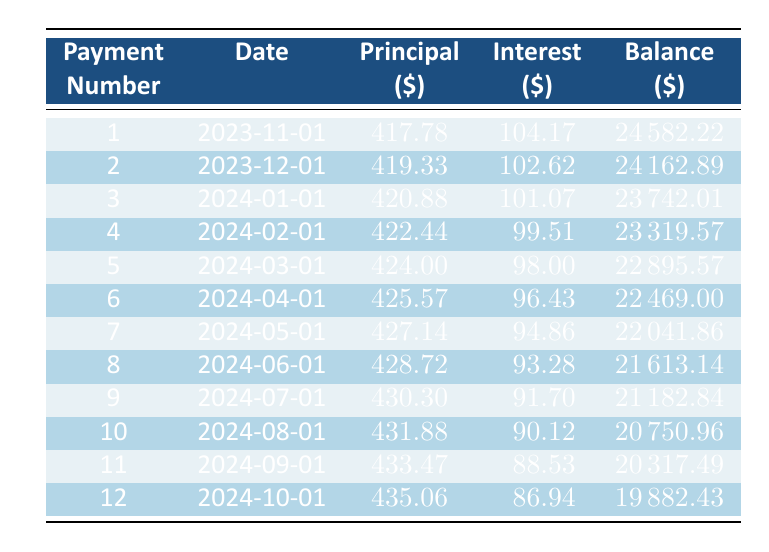What is the monthly payment for the car loan? The monthly payment for the car loan is mentioned directly in the data provided as 471.78.
Answer: 471.78 What is the principal payment for the first loan payment? The principal payment for the first loan payment is directly given in the table as 417.78.
Answer: 417.78 For which payment number is the interest payment the lowest? By reviewing the interest payment column, the lowest interest payment is observed with the 12th payment at 86.94.
Answer: 12 What is the remaining balance after the 6th payment? Looking at the remaining balance column, after the 6th payment, the value is 22469.00.
Answer: 22469.00 What is the total principal paid after the first four payments? To find the total principal paid, we sum the principal payments of the first four payments: 417.78 + 419.33 + 420.88 + 422.44 = 1680.43.
Answer: 1680.43 Is it true that the interest payment for the last payment is greater than the interest payment for the first payment? The interest payment for the last payment is 86.94 while the first payment is 104.17. Since 86.94 is less than 104.17, the statement is false.
Answer: No What is the average principal payment over the first 12 payments? To calculate the average, we sum the principal payments (417.78 + 419.33 + 420.88 + 422.44 + 424.00 + 425.57 + 427.14 + 428.72 + 430.30 + 431.88 + 433.47 + 435.06) which equals 5116.10 and divide by 12. The average is 5116.10 / 12 = 426.34.
Answer: 426.34 What is the total amount of interest paid after the first six payments? We sum the interest payments for the first six payments: 104.17 + 102.62 + 101.07 + 99.51 + 98.00 + 96.43 = 601.80 for the first half-year.
Answer: 601.80 After how many payments will the remaining balance fall below 20000? Tracking the remaining balances in the table, we see that after the 11th payment, the remaining balance is 20317.49 and after the 12th payment, it is 19882.43. Thus, it falls below 20000 after the 12th payment.
Answer: 12 